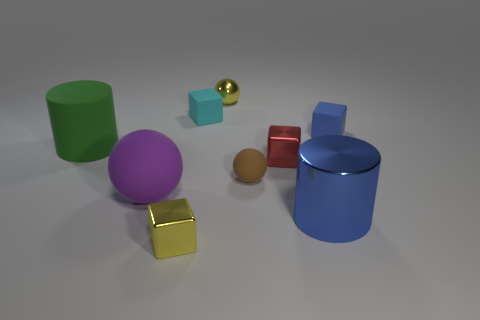How many blue objects have the same shape as the tiny cyan matte thing?
Provide a short and direct response. 1. Is the number of small metal spheres in front of the tiny brown thing the same as the number of purple objects behind the large green object?
Ensure brevity in your answer.  Yes. Are any tiny cyan objects visible?
Make the answer very short. Yes. There is a yellow shiny object that is behind the tiny object in front of the large metallic object on the right side of the tiny red metal object; what is its size?
Keep it short and to the point. Small. There is a cyan rubber object that is the same size as the yellow ball; what shape is it?
Your answer should be compact. Cube. Are there any other things that have the same material as the tiny brown ball?
Your response must be concise. Yes. How many objects are either blue things to the right of the big blue thing or blue metallic cylinders?
Offer a terse response. 2. There is a tiny ball behind the red shiny object that is right of the small cyan object; is there a large rubber thing on the right side of it?
Your answer should be very brief. No. How many purple shiny spheres are there?
Your answer should be compact. 0. How many things are big rubber objects that are on the left side of the big purple ball or tiny yellow metallic objects that are in front of the large metallic object?
Provide a succinct answer. 2. 